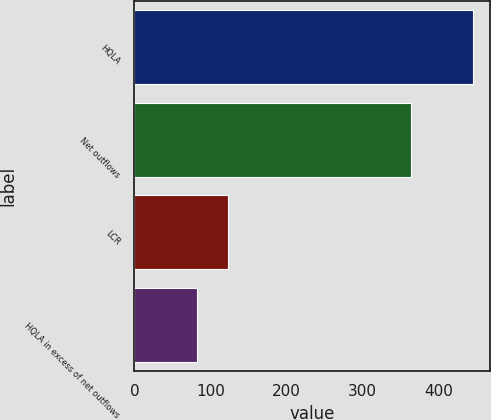Convert chart to OTSL. <chart><loc_0><loc_0><loc_500><loc_500><bar_chart><fcel>HQLA<fcel>Net outflows<fcel>LCR<fcel>HQLA in excess of net outflows<nl><fcel>446.4<fcel>364.3<fcel>123<fcel>82.1<nl></chart> 